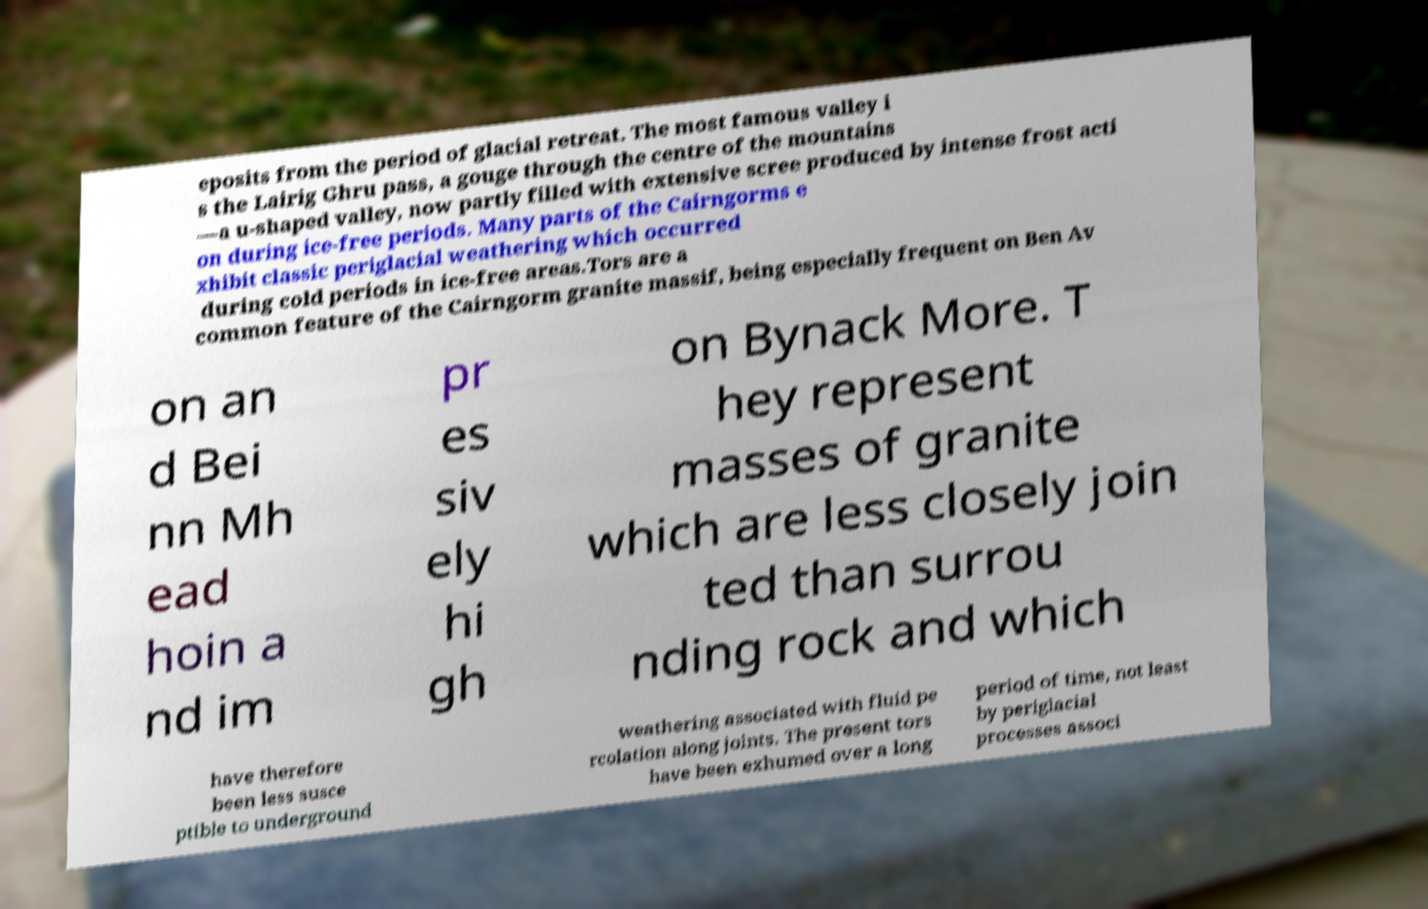For documentation purposes, I need the text within this image transcribed. Could you provide that? eposits from the period of glacial retreat. The most famous valley i s the Lairig Ghru pass, a gouge through the centre of the mountains —a u-shaped valley, now partly filled with extensive scree produced by intense frost acti on during ice-free periods. Many parts of the Cairngorms e xhibit classic periglacial weathering which occurred during cold periods in ice-free areas.Tors are a common feature of the Cairngorm granite massif, being especially frequent on Ben Av on an d Bei nn Mh ead hoin a nd im pr es siv ely hi gh on Bynack More. T hey represent masses of granite which are less closely join ted than surrou nding rock and which have therefore been less susce ptible to underground weathering associated with fluid pe rcolation along joints. The present tors have been exhumed over a long period of time, not least by periglacial processes associ 